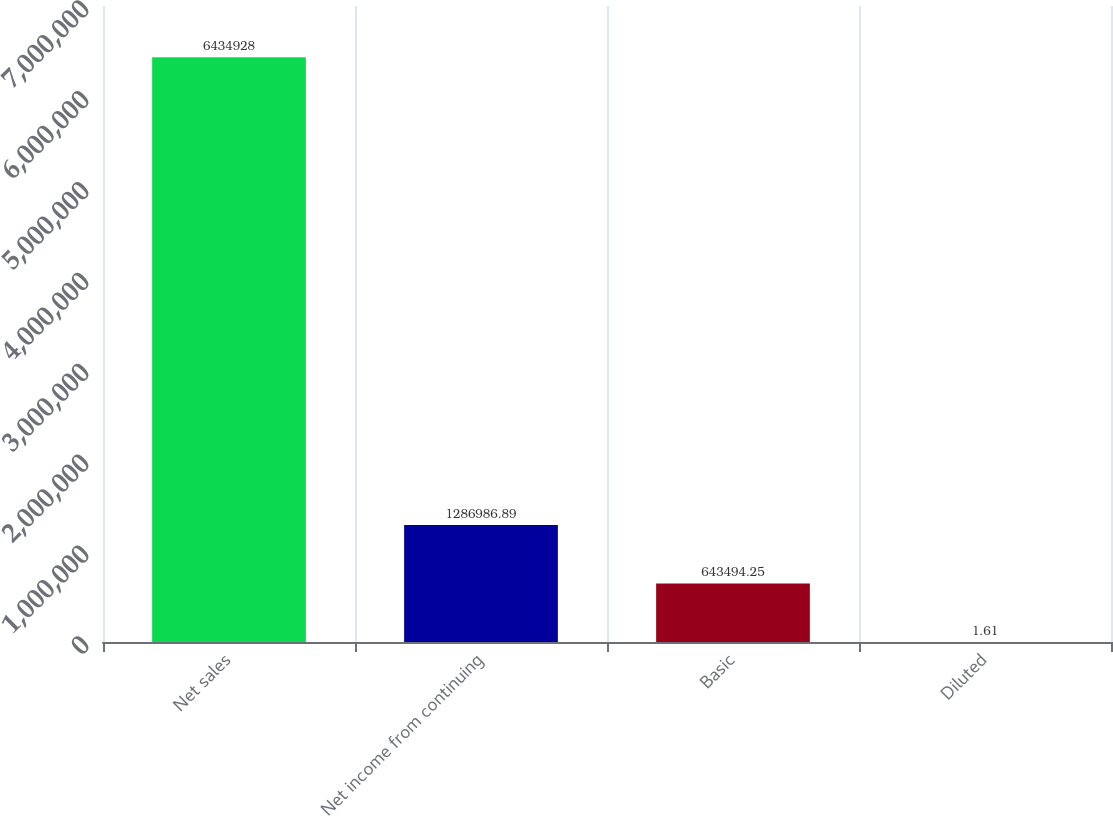Convert chart. <chart><loc_0><loc_0><loc_500><loc_500><bar_chart><fcel>Net sales<fcel>Net income from continuing<fcel>Basic<fcel>Diluted<nl><fcel>6.43493e+06<fcel>1.28699e+06<fcel>643494<fcel>1.61<nl></chart> 